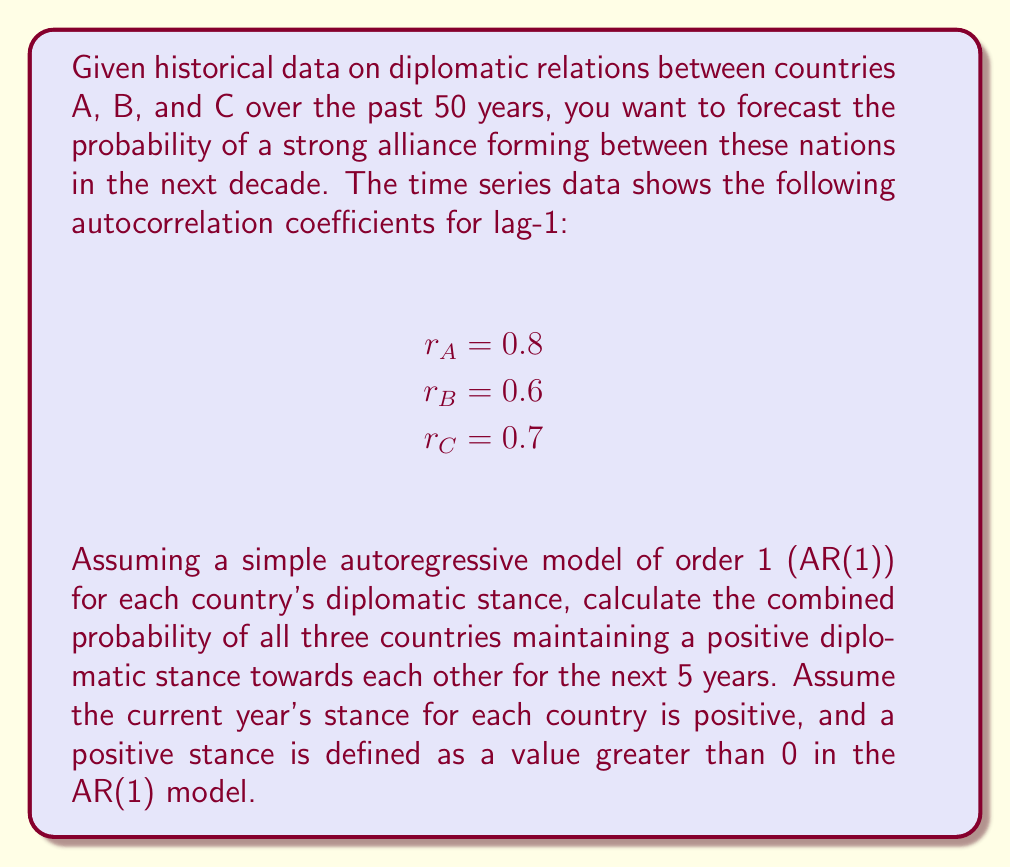Can you answer this question? To solve this problem, we'll use the properties of the AR(1) model and probability theory. Let's break it down step-by-step:

1) In an AR(1) model, the autocorrelation coefficient $r$ for lag-1 is equal to the model parameter $\phi$. So, we have:

   $\phi_A = 0.8$, $\phi_B = 0.6$, $\phi_C = 0.7$

2) In an AR(1) model, the probability of maintaining the same sign (positive or negative) after $n$ time periods is given by:

   $P(same sign) = \frac{1}{2} + \frac{1}{\pi} \arcsin(\phi^n)$

3) We need to calculate this probability for each country for $n = 5$ years:

   For country A: $P_A = \frac{1}{2} + \frac{1}{\pi} \arcsin(0.8^5) \approx 0.9052$
   For country B: $P_B = \frac{1}{2} + \frac{1}{\pi} \arcsin(0.6^5) \approx 0.8182$
   For country C: $P_C = \frac{1}{2} + \frac{1}{\pi} \arcsin(0.7^5) \approx 0.8632$

4) The probability of all three countries maintaining a positive stance is the product of their individual probabilities:

   $P(all positive) = P_A \times P_B \times P_C$

5) Substituting the values:

   $P(all positive) = 0.9052 \times 0.8182 \times 0.8632 \approx 0.6388$

Therefore, the probability of all three countries maintaining a positive diplomatic stance towards each other for the next 5 years is approximately 0.6388 or 63.88%.
Answer: 0.6388 or 63.88% 